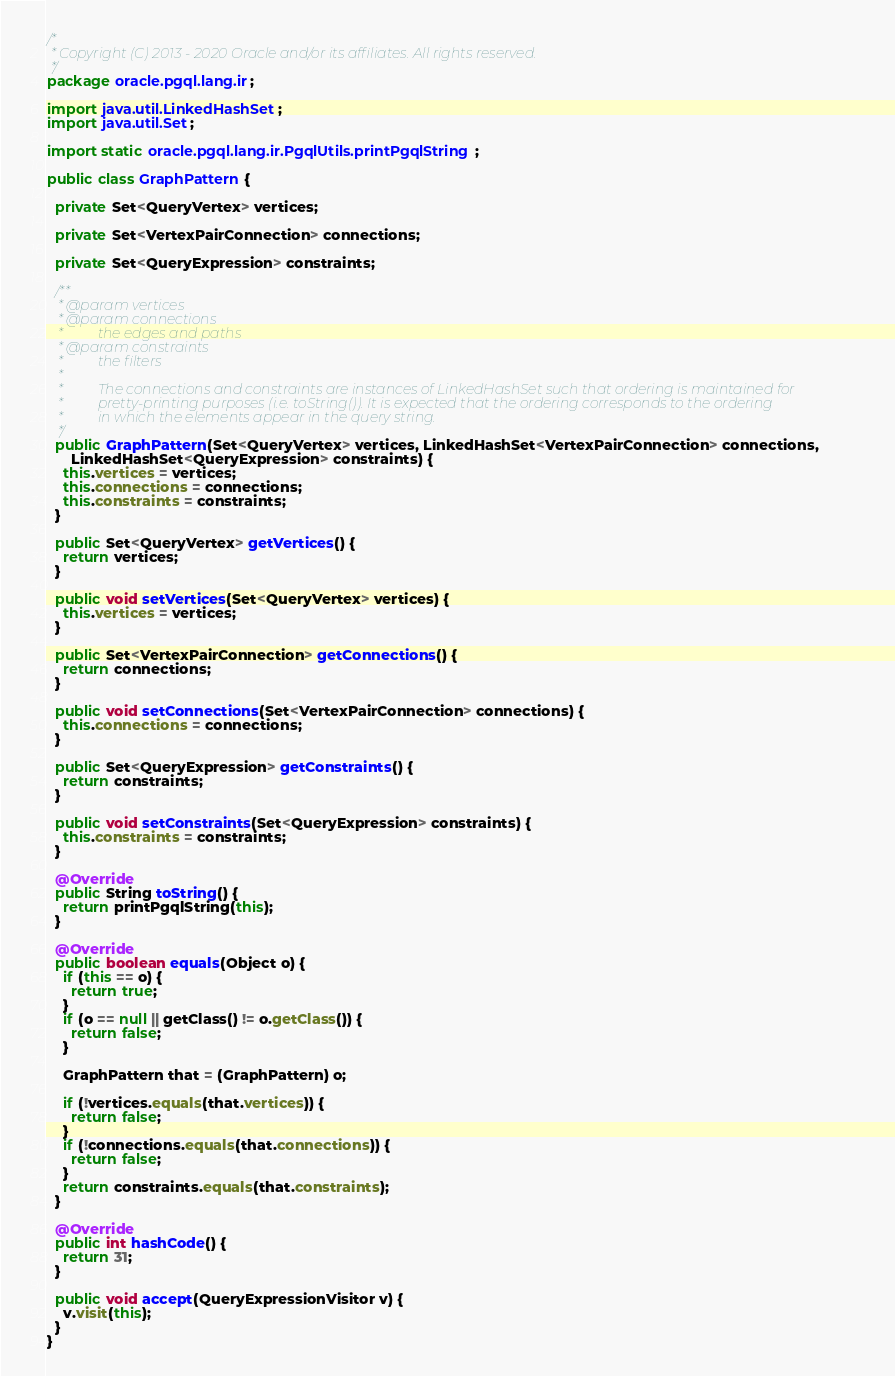Convert code to text. <code><loc_0><loc_0><loc_500><loc_500><_Java_>/*
 * Copyright (C) 2013 - 2020 Oracle and/or its affiliates. All rights reserved.
 */
package oracle.pgql.lang.ir;

import java.util.LinkedHashSet;
import java.util.Set;

import static oracle.pgql.lang.ir.PgqlUtils.printPgqlString;

public class GraphPattern {

  private Set<QueryVertex> vertices;

  private Set<VertexPairConnection> connections;

  private Set<QueryExpression> constraints;

  /**
   * @param vertices
   * @param connections
   *          the edges and paths
   * @param constraints
   *          the filters
   *
   *          The connections and constraints are instances of LinkedHashSet such that ordering is maintained for
   *          pretty-printing purposes (i.e. toString()). It is expected that the ordering corresponds to the ordering
   *          in which the elements appear in the query string.
   */
  public GraphPattern(Set<QueryVertex> vertices, LinkedHashSet<VertexPairConnection> connections,
      LinkedHashSet<QueryExpression> constraints) {
    this.vertices = vertices;
    this.connections = connections;
    this.constraints = constraints;
  }

  public Set<QueryVertex> getVertices() {
    return vertices;
  }

  public void setVertices(Set<QueryVertex> vertices) {
    this.vertices = vertices;
  }

  public Set<VertexPairConnection> getConnections() {
    return connections;
  }

  public void setConnections(Set<VertexPairConnection> connections) {
    this.connections = connections;
  }

  public Set<QueryExpression> getConstraints() {
    return constraints;
  }

  public void setConstraints(Set<QueryExpression> constraints) {
    this.constraints = constraints;
  }

  @Override
  public String toString() {
    return printPgqlString(this);
  }

  @Override
  public boolean equals(Object o) {
    if (this == o) {
      return true;
    }
    if (o == null || getClass() != o.getClass()) {
      return false;
    }

    GraphPattern that = (GraphPattern) o;

    if (!vertices.equals(that.vertices)) {
      return false;
    }
    if (!connections.equals(that.connections)) {
      return false;
    }
    return constraints.equals(that.constraints);
  }

  @Override
  public int hashCode() {
    return 31;
  }

  public void accept(QueryExpressionVisitor v) {
    v.visit(this);
  }
}
</code> 